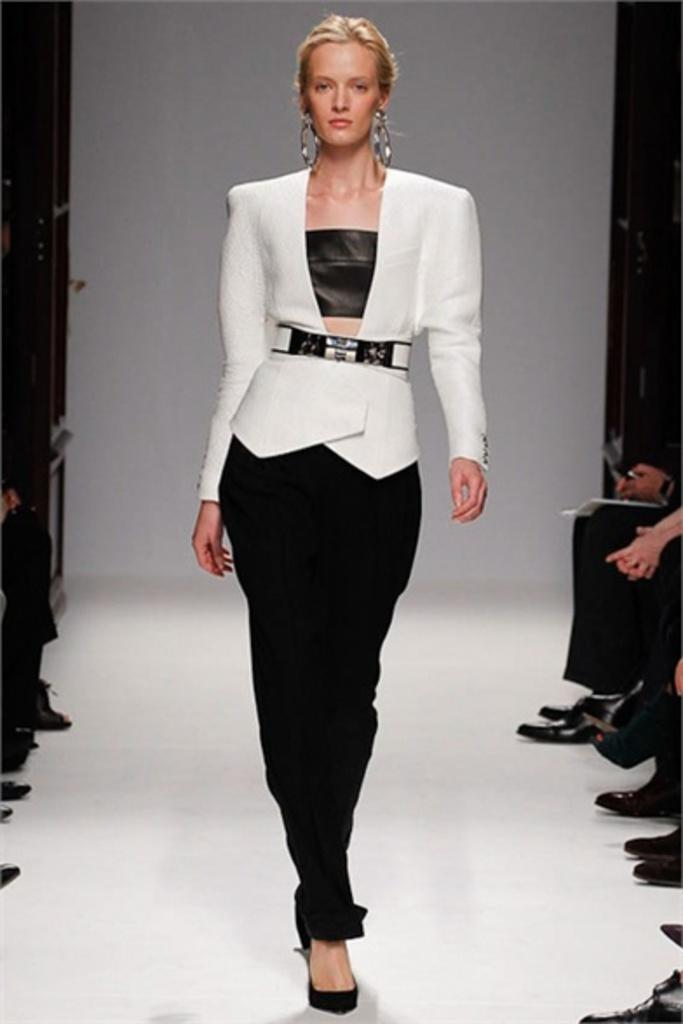What can be seen on the left side of the image? There are people on the left side of the image. What can be seen on the right side of the image? There are people on the right side of the image. What is the central figure in the image? There is a woman in the middle of the image. What is visible in the background of the image? There is a wall in the background of the image. What type of boat can be seen in the image? There is no boat present in the image. Is there a tent visible in the image? There is no tent present in the image. 